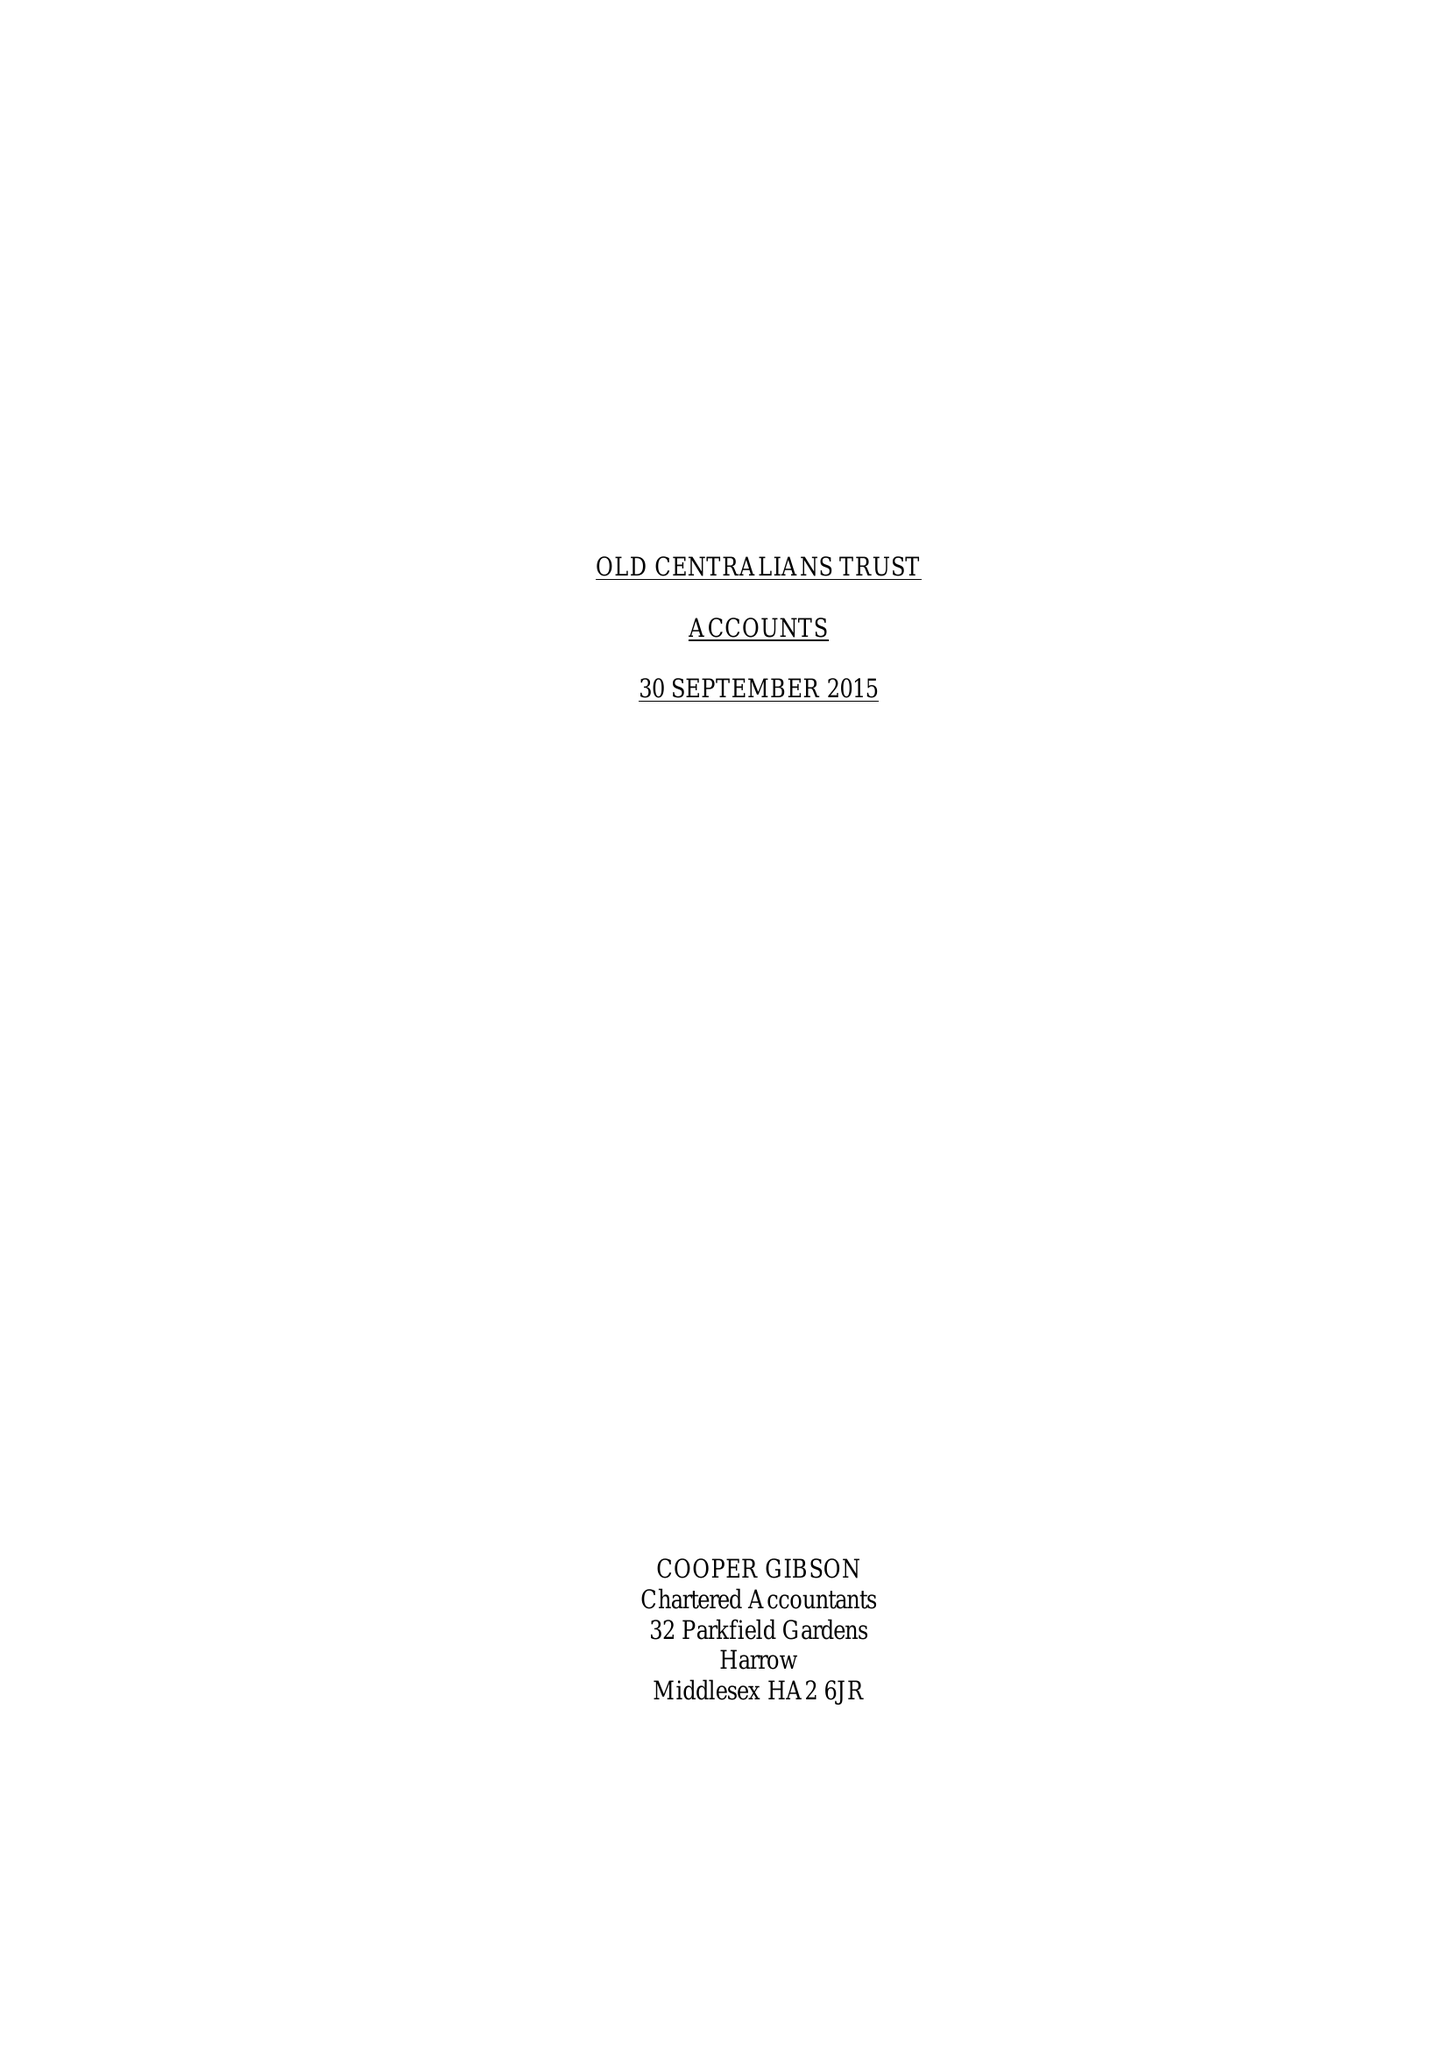What is the value for the address__post_town?
Answer the question using a single word or phrase. LONDON 